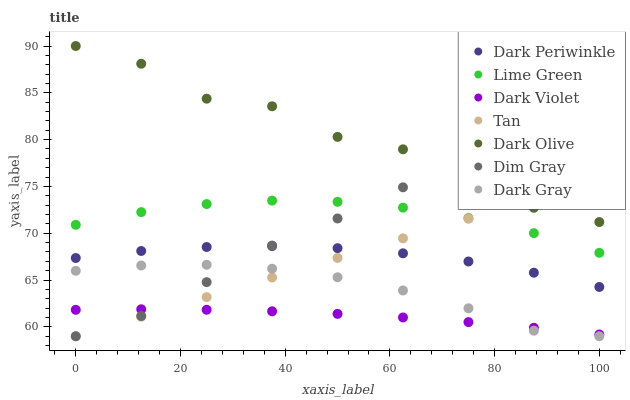Does Dark Violet have the minimum area under the curve?
Answer yes or no. Yes. Does Dark Olive have the maximum area under the curve?
Answer yes or no. Yes. Does Dark Olive have the minimum area under the curve?
Answer yes or no. No. Does Dark Violet have the maximum area under the curve?
Answer yes or no. No. Is Tan the smoothest?
Answer yes or no. Yes. Is Dark Olive the roughest?
Answer yes or no. Yes. Is Dark Violet the smoothest?
Answer yes or no. No. Is Dark Violet the roughest?
Answer yes or no. No. Does Dim Gray have the lowest value?
Answer yes or no. Yes. Does Dark Violet have the lowest value?
Answer yes or no. No. Does Dark Olive have the highest value?
Answer yes or no. Yes. Does Dark Violet have the highest value?
Answer yes or no. No. Is Dark Gray less than Dark Periwinkle?
Answer yes or no. Yes. Is Lime Green greater than Dark Gray?
Answer yes or no. Yes. Does Dim Gray intersect Dark Periwinkle?
Answer yes or no. Yes. Is Dim Gray less than Dark Periwinkle?
Answer yes or no. No. Is Dim Gray greater than Dark Periwinkle?
Answer yes or no. No. Does Dark Gray intersect Dark Periwinkle?
Answer yes or no. No. 